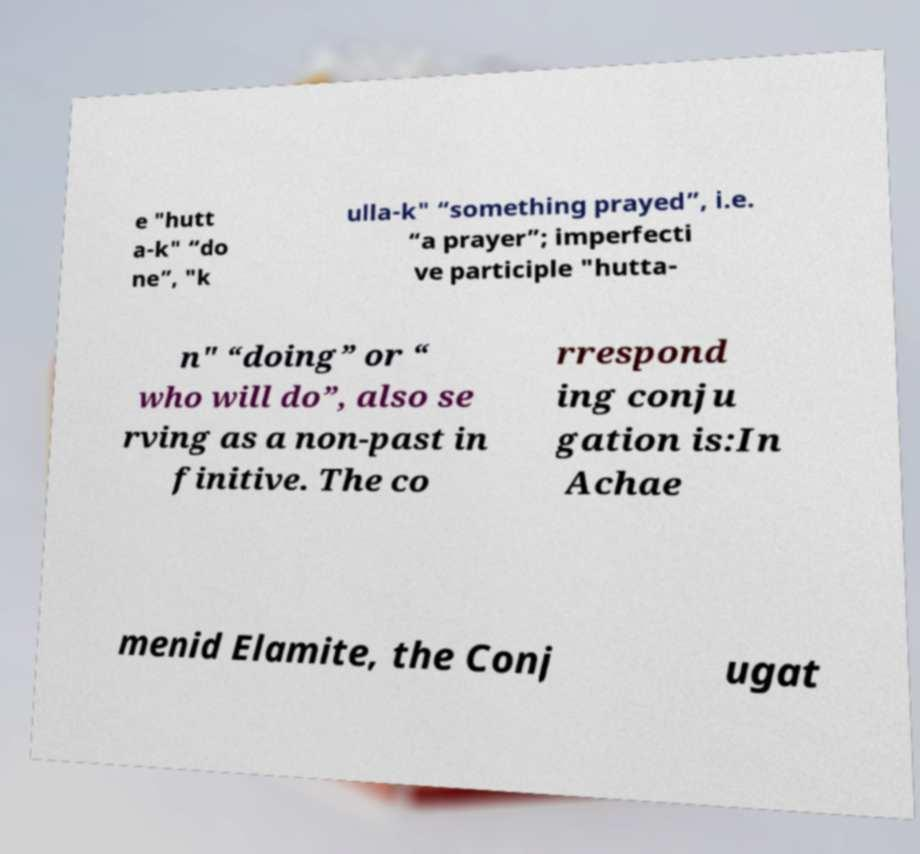For documentation purposes, I need the text within this image transcribed. Could you provide that? e "hutt a-k" “do ne”, "k ulla-k" “something prayed”, i.e. “a prayer”; imperfecti ve participle "hutta- n" “doing” or “ who will do”, also se rving as a non-past in finitive. The co rrespond ing conju gation is:In Achae menid Elamite, the Conj ugat 